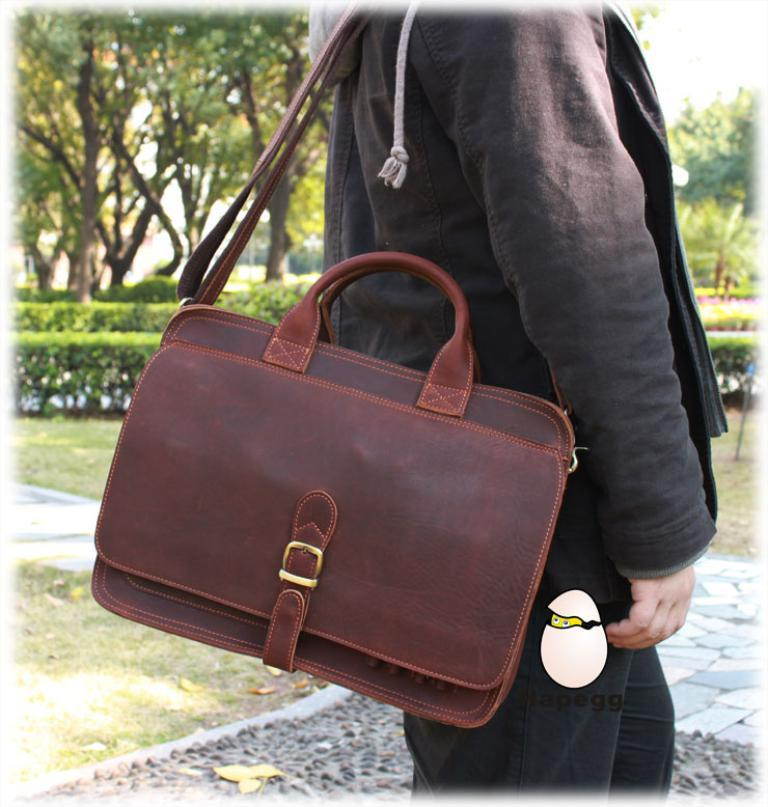Who or what is present in the image? There is a person in the image. What is the person wearing? The person is wearing a black dress. Is the person carrying anything? Yes, the person is carrying a bag. What can be seen in the background of the image? There are trees in the background of the image. What type of amusement park can be seen in the background of the image? There is no amusement park present in the image; the background features trees. 